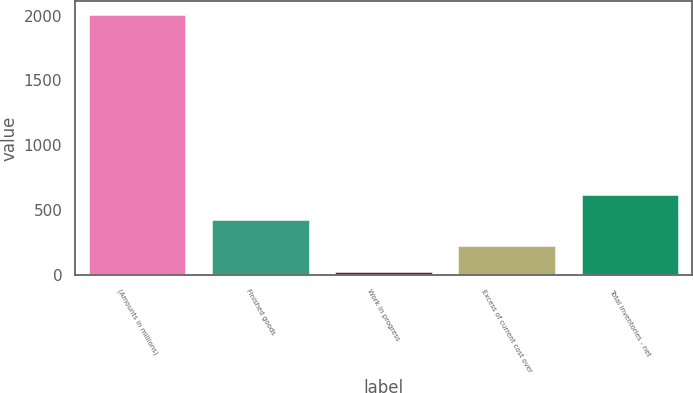Convert chart. <chart><loc_0><loc_0><loc_500><loc_500><bar_chart><fcel>(Amounts in millions)<fcel>Finished goods<fcel>Work in progress<fcel>Excess of current cost over<fcel>Total inventories - net<nl><fcel>2011<fcel>427.96<fcel>32.2<fcel>230.08<fcel>625.84<nl></chart> 